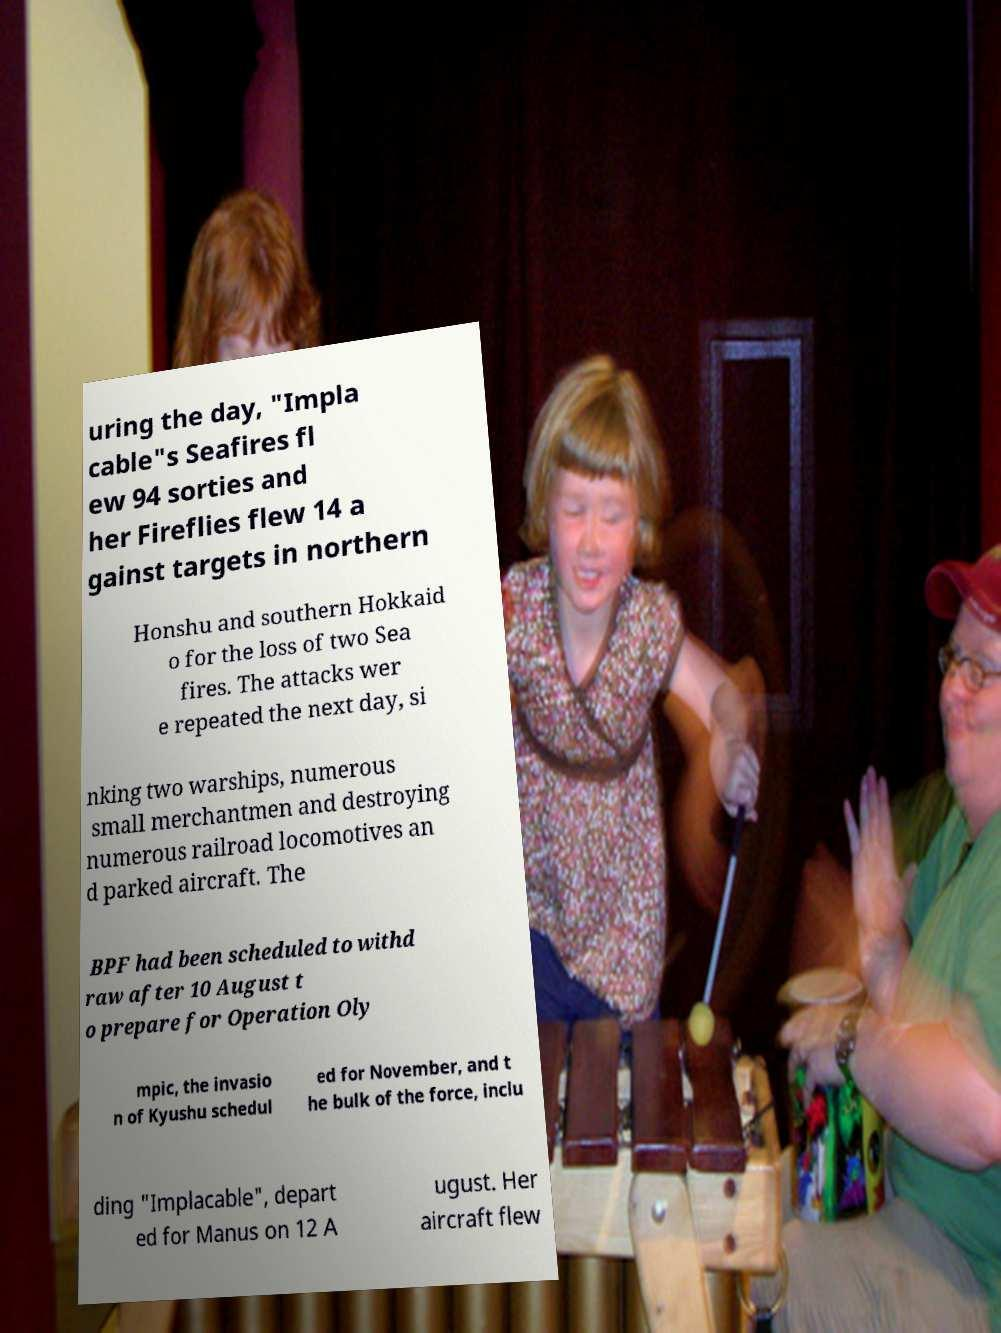Could you assist in decoding the text presented in this image and type it out clearly? uring the day, "Impla cable"s Seafires fl ew 94 sorties and her Fireflies flew 14 a gainst targets in northern Honshu and southern Hokkaid o for the loss of two Sea fires. The attacks wer e repeated the next day, si nking two warships, numerous small merchantmen and destroying numerous railroad locomotives an d parked aircraft. The BPF had been scheduled to withd raw after 10 August t o prepare for Operation Oly mpic, the invasio n of Kyushu schedul ed for November, and t he bulk of the force, inclu ding "Implacable", depart ed for Manus on 12 A ugust. Her aircraft flew 